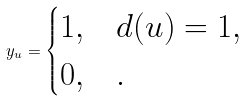<formula> <loc_0><loc_0><loc_500><loc_500>y _ { u } = \begin{cases} 1 , & d ( u ) = 1 , \\ 0 , & . \end{cases}</formula> 